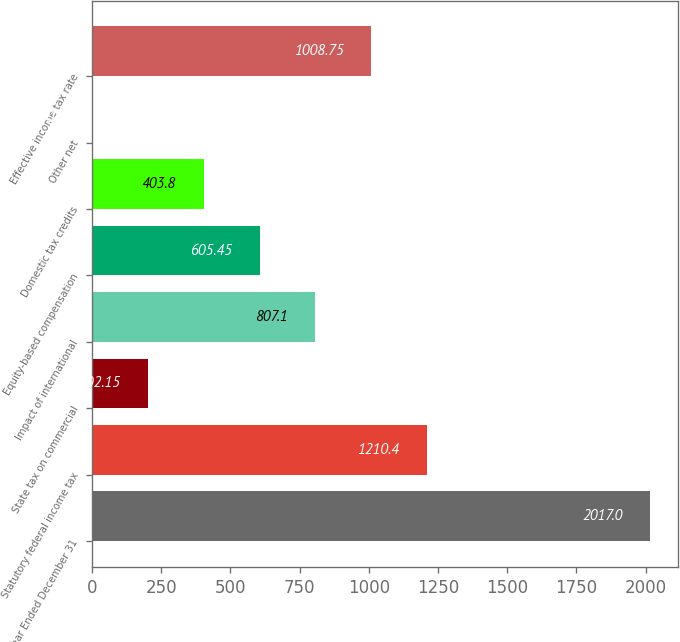Convert chart. <chart><loc_0><loc_0><loc_500><loc_500><bar_chart><fcel>Year Ended December 31<fcel>Statutory federal income tax<fcel>State tax on commercial<fcel>Impact of international<fcel>Equity-based compensation<fcel>Domestic tax credits<fcel>Other net<fcel>Effective income tax rate<nl><fcel>2017<fcel>1210.4<fcel>202.15<fcel>807.1<fcel>605.45<fcel>403.8<fcel>0.5<fcel>1008.75<nl></chart> 